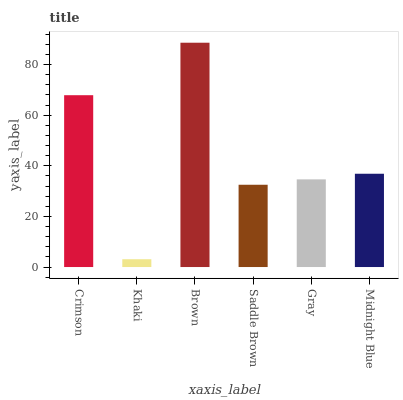Is Khaki the minimum?
Answer yes or no. Yes. Is Brown the maximum?
Answer yes or no. Yes. Is Brown the minimum?
Answer yes or no. No. Is Khaki the maximum?
Answer yes or no. No. Is Brown greater than Khaki?
Answer yes or no. Yes. Is Khaki less than Brown?
Answer yes or no. Yes. Is Khaki greater than Brown?
Answer yes or no. No. Is Brown less than Khaki?
Answer yes or no. No. Is Midnight Blue the high median?
Answer yes or no. Yes. Is Gray the low median?
Answer yes or no. Yes. Is Gray the high median?
Answer yes or no. No. Is Saddle Brown the low median?
Answer yes or no. No. 